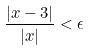Convert formula to latex. <formula><loc_0><loc_0><loc_500><loc_500>\frac { | x - 3 | } { | x | } < \epsilon</formula> 